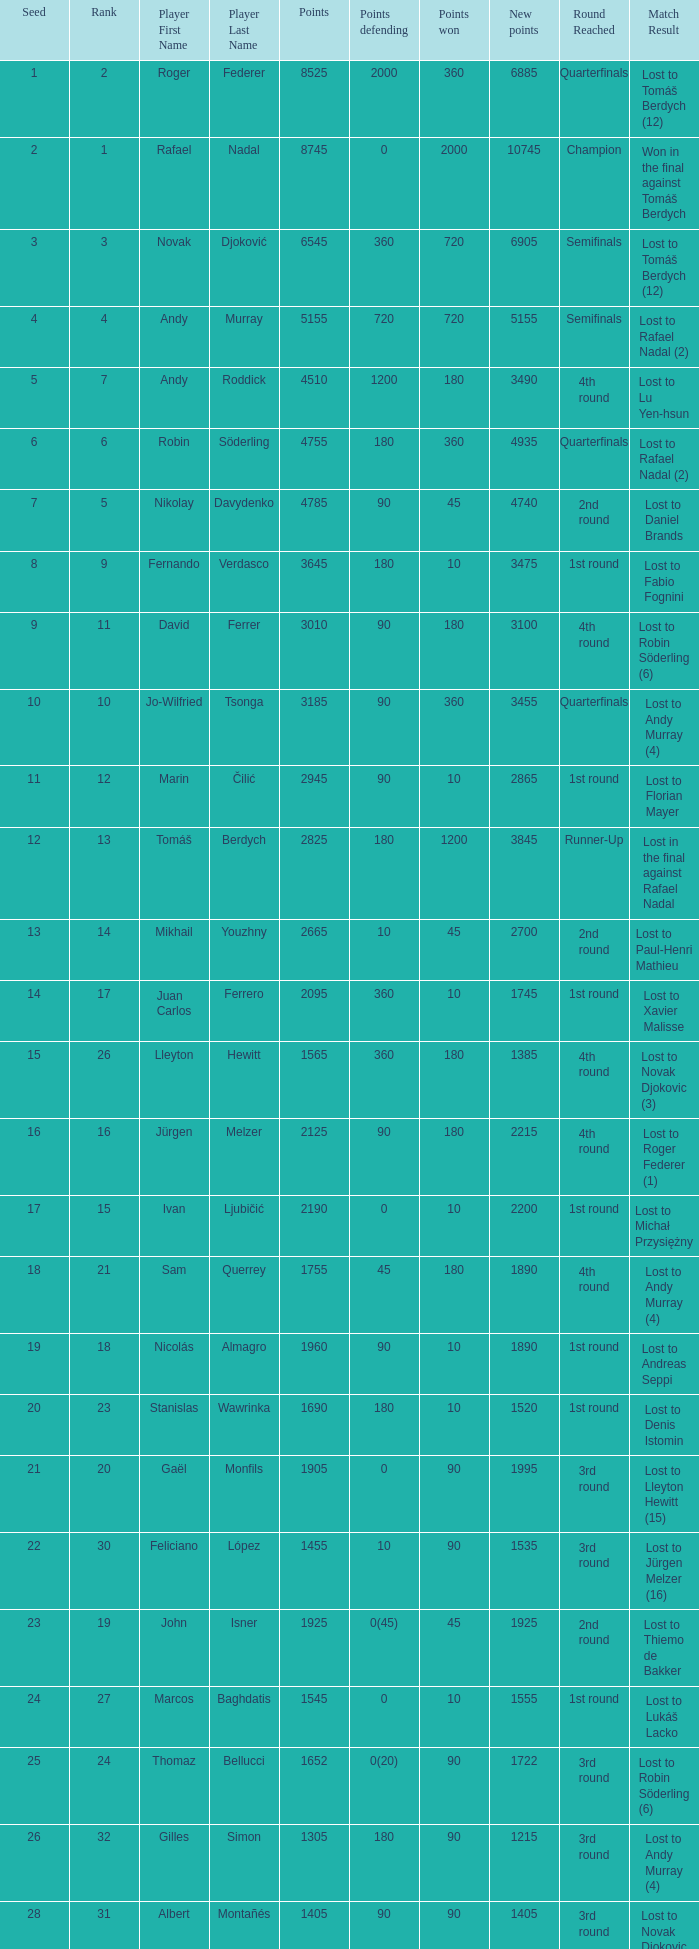Name the status for points 3185 Quarterfinals lost to Andy Murray (4). 